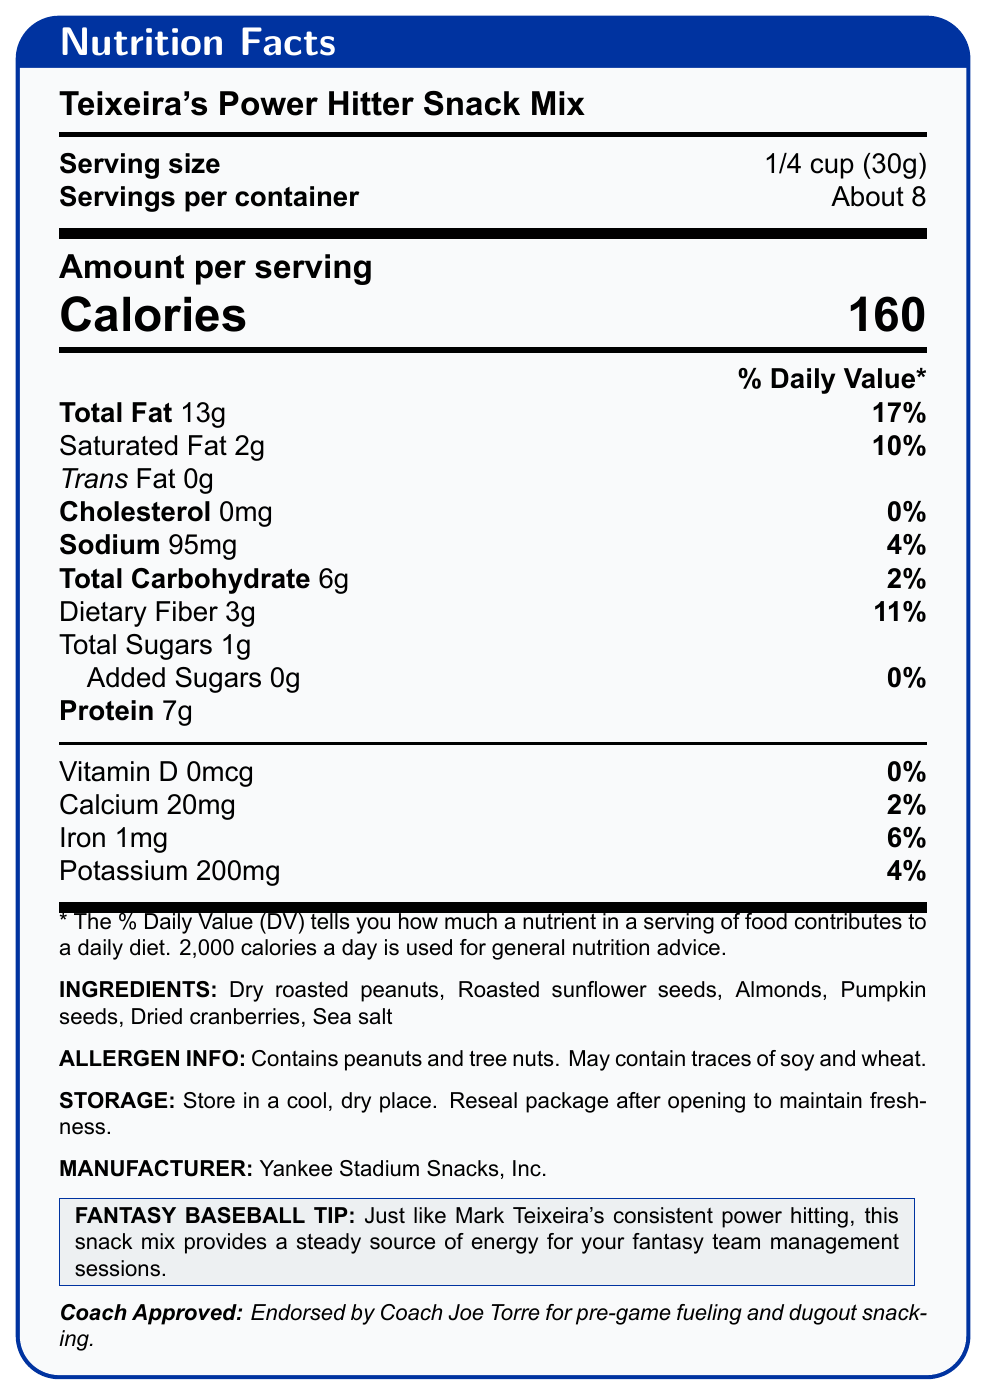how many calories are in one serving? The document specifies that the number of calories per serving is 160.
Answer: 160 what is the serving size? The serving size is explicitly stated as 1/4 cup (30g).
Answer: 1/4 cup (30g) what percentage of the daily value of saturated fat does one serving contain? According to the document, one serving contains 10% of the daily value for saturated fat.
Answer: 10% how much protein is in a serving of the snack mix? The protein content per serving is clearly listed as 7g.
Answer: 7g how much potassium does each serving of the snack mix provide? The nutrient section lists potassium content as 200mg.
Answer: 200mg how many total servings are in one container? A. 6 B. 7 C. 8 D. 9 The document mentions that there are about 8 servings per container.
Answer: C. 8 what ingredients are included in Teixeira's Power Hitter Snack Mix? A. Peanuts, almonds, cranberries B. Walnuts, soy, raisins C. Peanuts, hazelnuts, blueberries The ingredients listed include dry roasted peanuts, almonds, dried cranberries, and others.
Answer: A. Peanuts, almonds, cranberries is the snack mix endorsed by a baseball coach? The document states that it is endorsed by Coach Joe Torre for pre-game fueling and dugout snacking.
Answer: Yes what is a special tip provided for fantasy baseball players? The fantasy baseball tip is provided in the special info section at the end of the document.
Answer: Just like Mark Teixeira's consistent power hitting, this snack mix provides a steady source of energy for your fantasy team management sessions. does the snack mix contain trans fat? True/False The document lists the trans fat content as 0g, indicating it contains no trans fat.
Answer: False what allergens are present in the snack mix? The allergen information section states it contains peanuts and tree nuts, and may contain traces of soy and wheat.
Answer: Peanuts and tree nuts. May contain traces of soy and wheat. what are the storage instructions for the snack mix? The document mentions the snack should be stored in a cool, dry place and the package should be resealed after opening.
Answer: Store in a cool, dry place. Reseal package after opening to maintain freshness. describe the main idea of the document. This document aims to inform consumers about the nutritional facts and other essential details of Teixeira's Power Hitter Snack Mix, helping them make informed dietary choices.
Answer: The document provides the nutritional information for Teixeira's Power Hitter Snack Mix. It details the serving size, calories, nutrient content, ingredients, allergen information, storage instructions, and endorsements from a baseball coach. There is also a special tip for fantasy baseball players. what is the origin of the peanuts used in the snack mix? The document does not provide details about the origin of the peanuts used in the snack mix.
Answer: Not enough information 